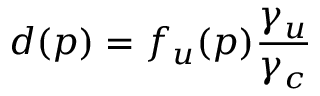<formula> <loc_0><loc_0><loc_500><loc_500>d ( p ) = f _ { u } ( p ) { \frac { \gamma _ { u } } { \gamma _ { c } } }</formula> 